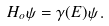Convert formula to latex. <formula><loc_0><loc_0><loc_500><loc_500>H _ { o } \psi = \gamma ( E ) \psi \, .</formula> 